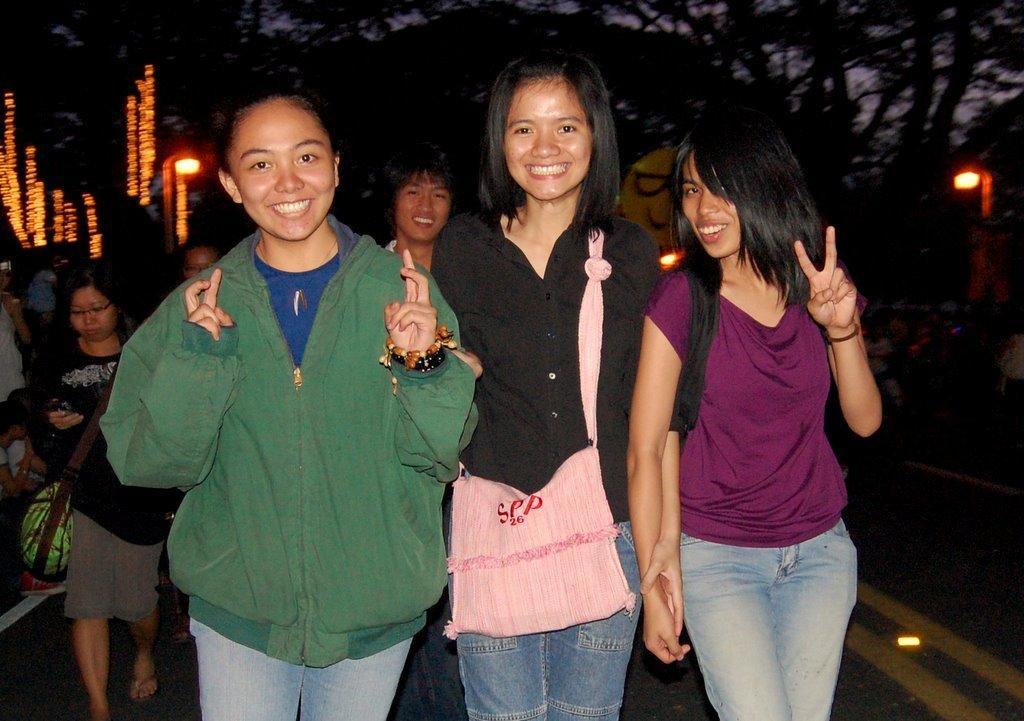Could you give a brief overview of what you see in this image? In the image there are three ladies standing and they are smiling. The lady in the middle is wearing a bag. Behind them there are few people. And also there are trees and lights in the background. 